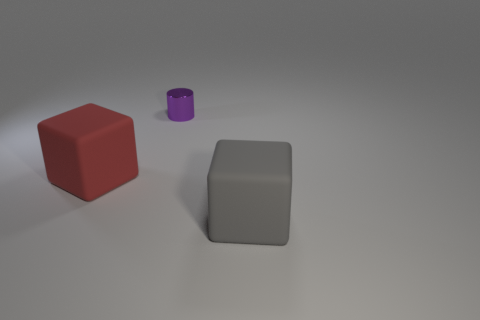What is the color of the large rubber thing that is right of the large rubber block behind the gray rubber cube?
Provide a short and direct response. Gray. There is a rubber object to the right of the big block that is behind the large matte block that is right of the red rubber cube; what is its size?
Provide a succinct answer. Large. Are there fewer purple shiny objects behind the purple thing than large things that are in front of the red rubber block?
Offer a very short reply. Yes. How many red blocks have the same material as the big red thing?
Your answer should be very brief. 0. Are there any red matte things on the left side of the rubber object on the left side of the large rubber block that is right of the big red rubber thing?
Provide a succinct answer. No. There is a object that is made of the same material as the big red cube; what shape is it?
Ensure brevity in your answer.  Cube. Are there more small metal things than brown rubber cylinders?
Provide a succinct answer. Yes. Does the tiny purple object have the same shape as the big thing that is to the right of the tiny cylinder?
Keep it short and to the point. No. What is the material of the purple object?
Offer a very short reply. Metal. What color is the large block to the left of the purple thing that is on the left side of the big object on the right side of the cylinder?
Give a very brief answer. Red. 